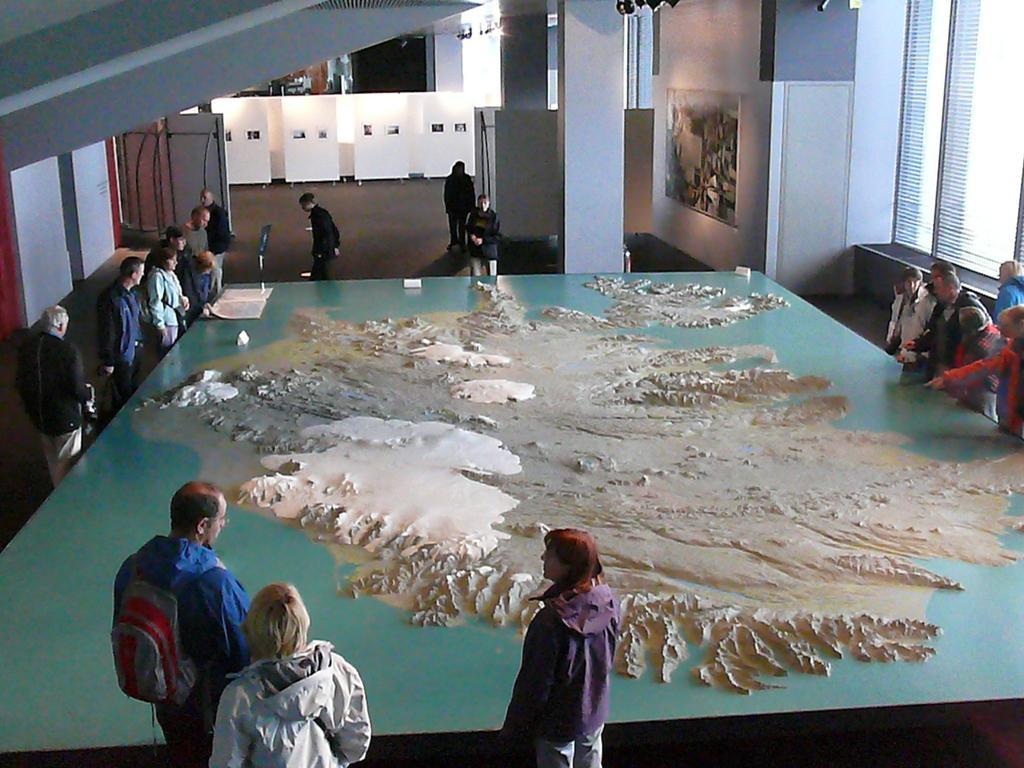In one or two sentences, can you explain what this image depicts? In the center of the image there is a table. On the table we can see some art, boards, book. Beside the table some persons are standing. In the background of the image we can see wall, hoards, pillars. At the top of the image we can see roof and lights. On the right side of the image there is a window. 